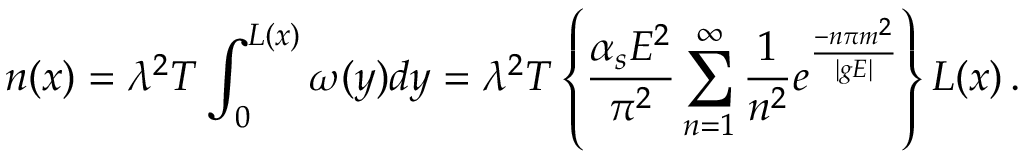Convert formula to latex. <formula><loc_0><loc_0><loc_500><loc_500>n ( x ) = \lambda ^ { 2 } T \int _ { 0 } ^ { L ( x ) } \omega ( y ) d y = \lambda ^ { 2 } T \left \{ \frac { \alpha _ { s } E ^ { 2 } } { \pi ^ { 2 } } \sum _ { n = 1 } ^ { \infty } \frac { 1 } { n ^ { 2 } } e ^ { \frac { - n \pi m ^ { 2 } } { | g E | } } \right \} L ( x ) \, .</formula> 